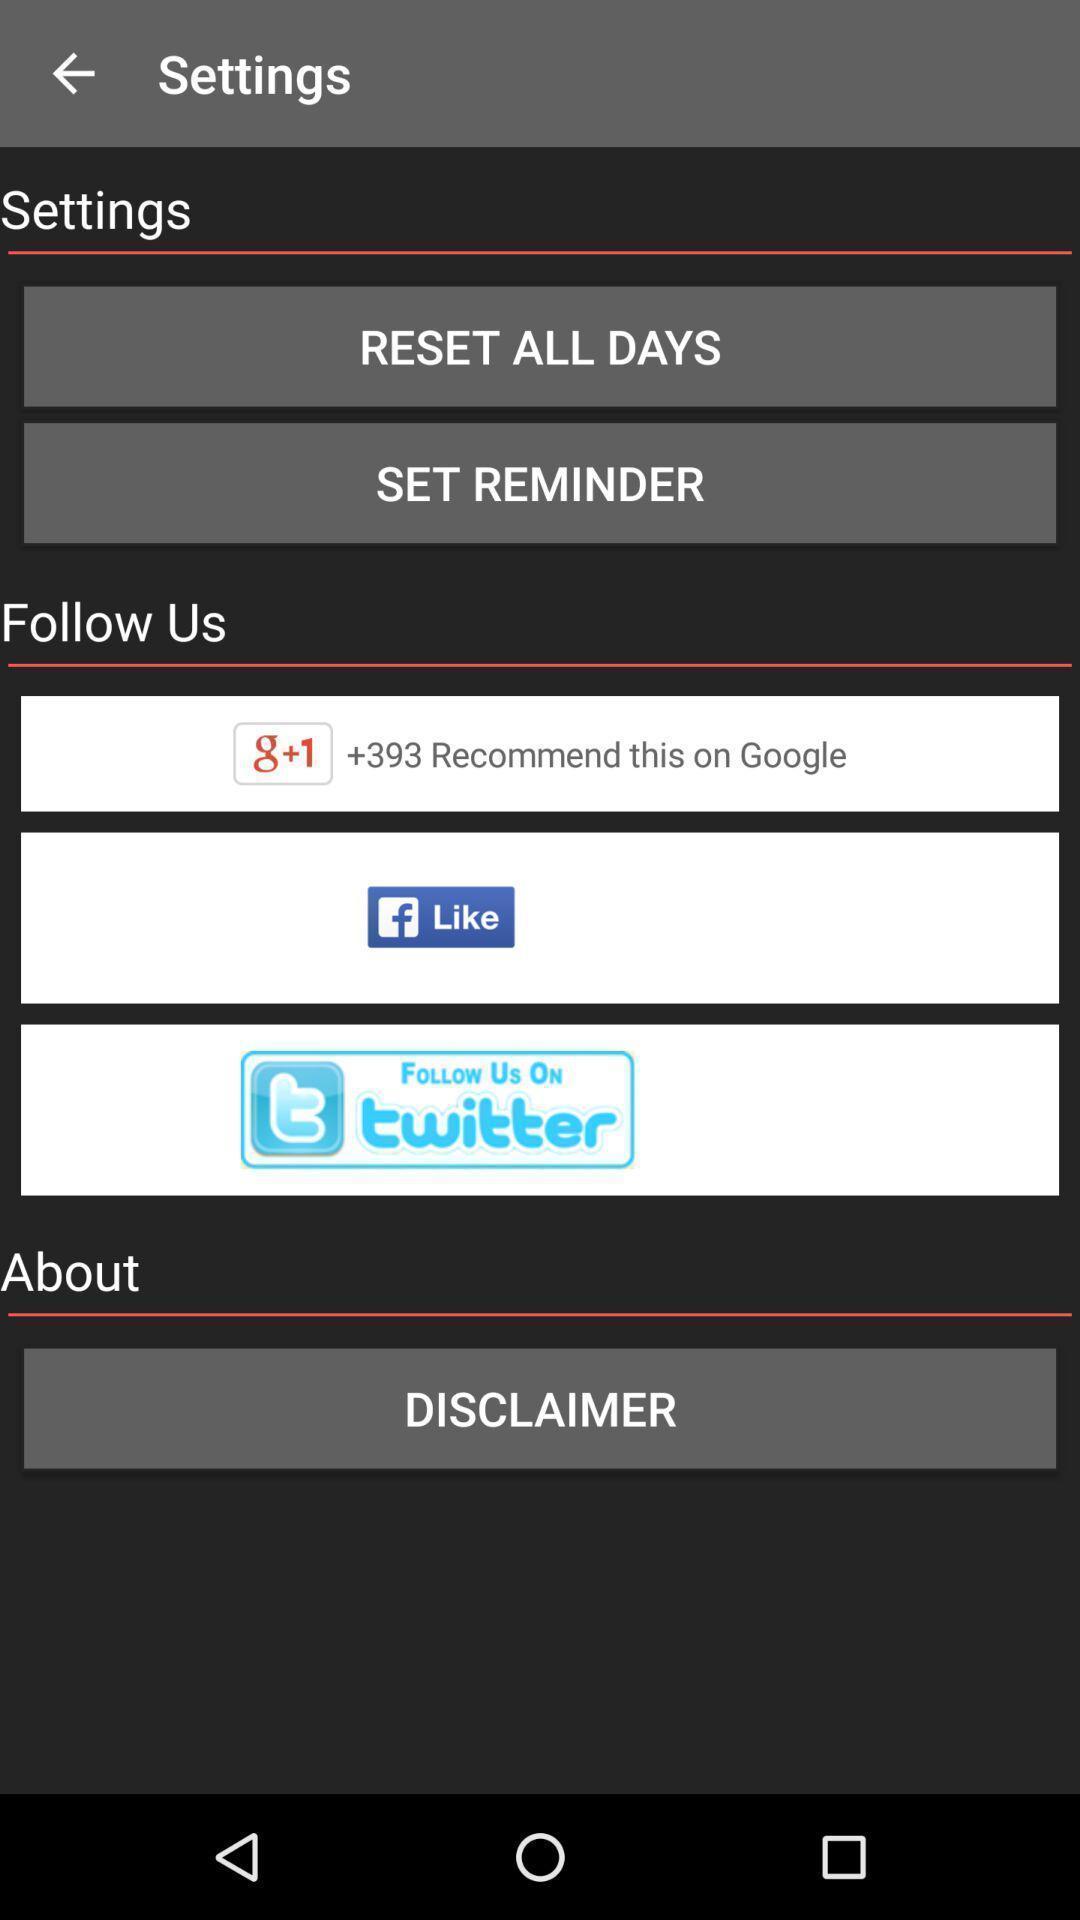Give me a narrative description of this picture. Settings page with options. 